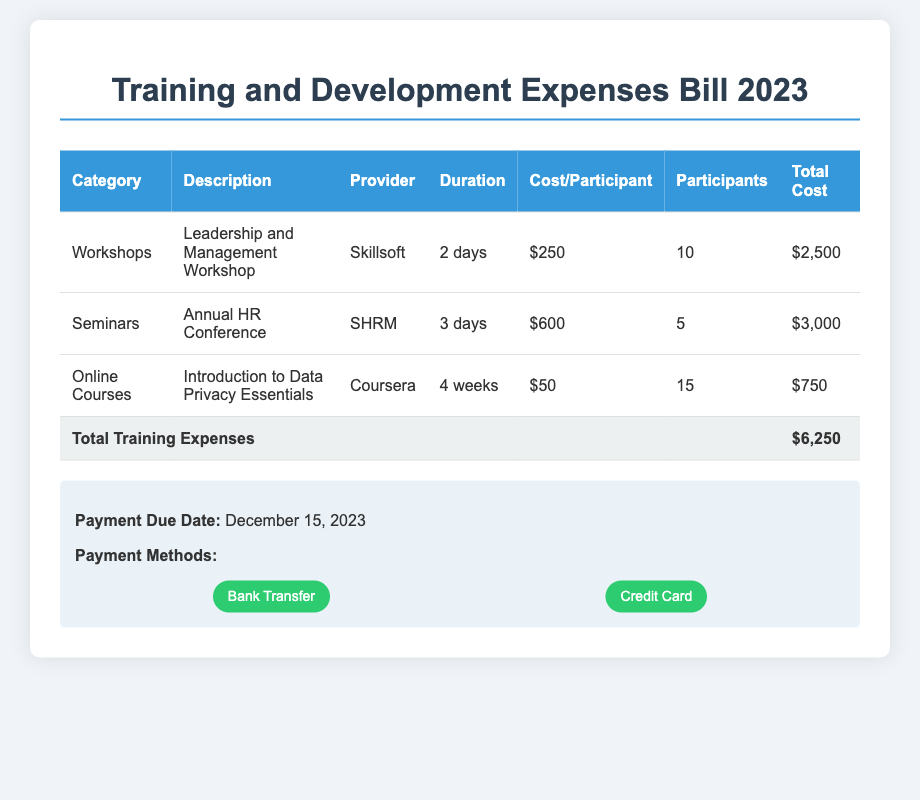What is the total cost for workshops? The total cost for workshops is specified in the table and can be found in the last column for the workshops category.
Answer: $2,500 How many participants attended the Annual HR Conference? The number of participants for the Annual HR Conference is shown in the relevant row under the Participants column.
Answer: 5 What is the name of the online course offered? The name of the online course is specified in the Description column for the Online Courses category.
Answer: Introduction to Data Privacy Essentials What is the duration of the Leadership and Management Workshop? The duration is noted in the Duration column of the workshops section of the table.
Answer: 2 days What is the payment due date? The payment due date is mentioned at the end of the document in the payment information section.
Answer: December 15, 2023 Which provider conducted the Leadership and Management Workshop? The provider for the Leadership and Management Workshop is listed in the Provider column of the table.
Answer: Skillsoft What is the total amount of training expenses? The total training expenses can be found in the last row of the table, summarizing all costs.
Answer: $6,250 How many weeks did the online course last? The duration of the online course can be found in the Duration column of the Online Courses section.
Answer: 4 weeks What are the two payment methods listed? The payment methods are mentioned in the payment information section and are specific to how payments can be made.
Answer: Bank Transfer, Credit Card 